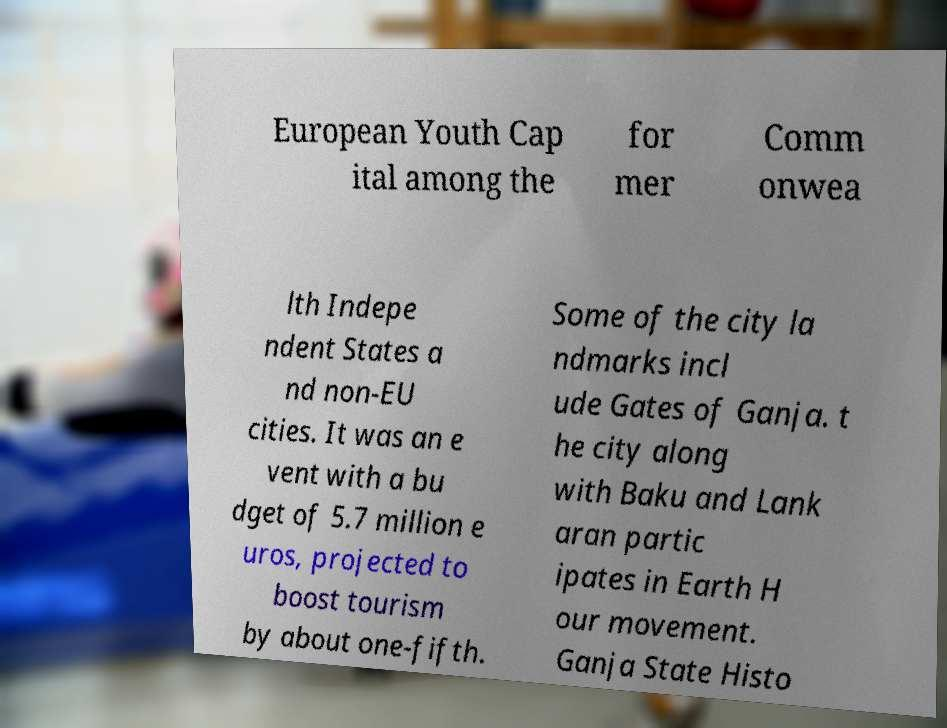Can you accurately transcribe the text from the provided image for me? European Youth Cap ital among the for mer Comm onwea lth Indepe ndent States a nd non-EU cities. It was an e vent with a bu dget of 5.7 million e uros, projected to boost tourism by about one-fifth. Some of the city la ndmarks incl ude Gates of Ganja. t he city along with Baku and Lank aran partic ipates in Earth H our movement. Ganja State Histo 